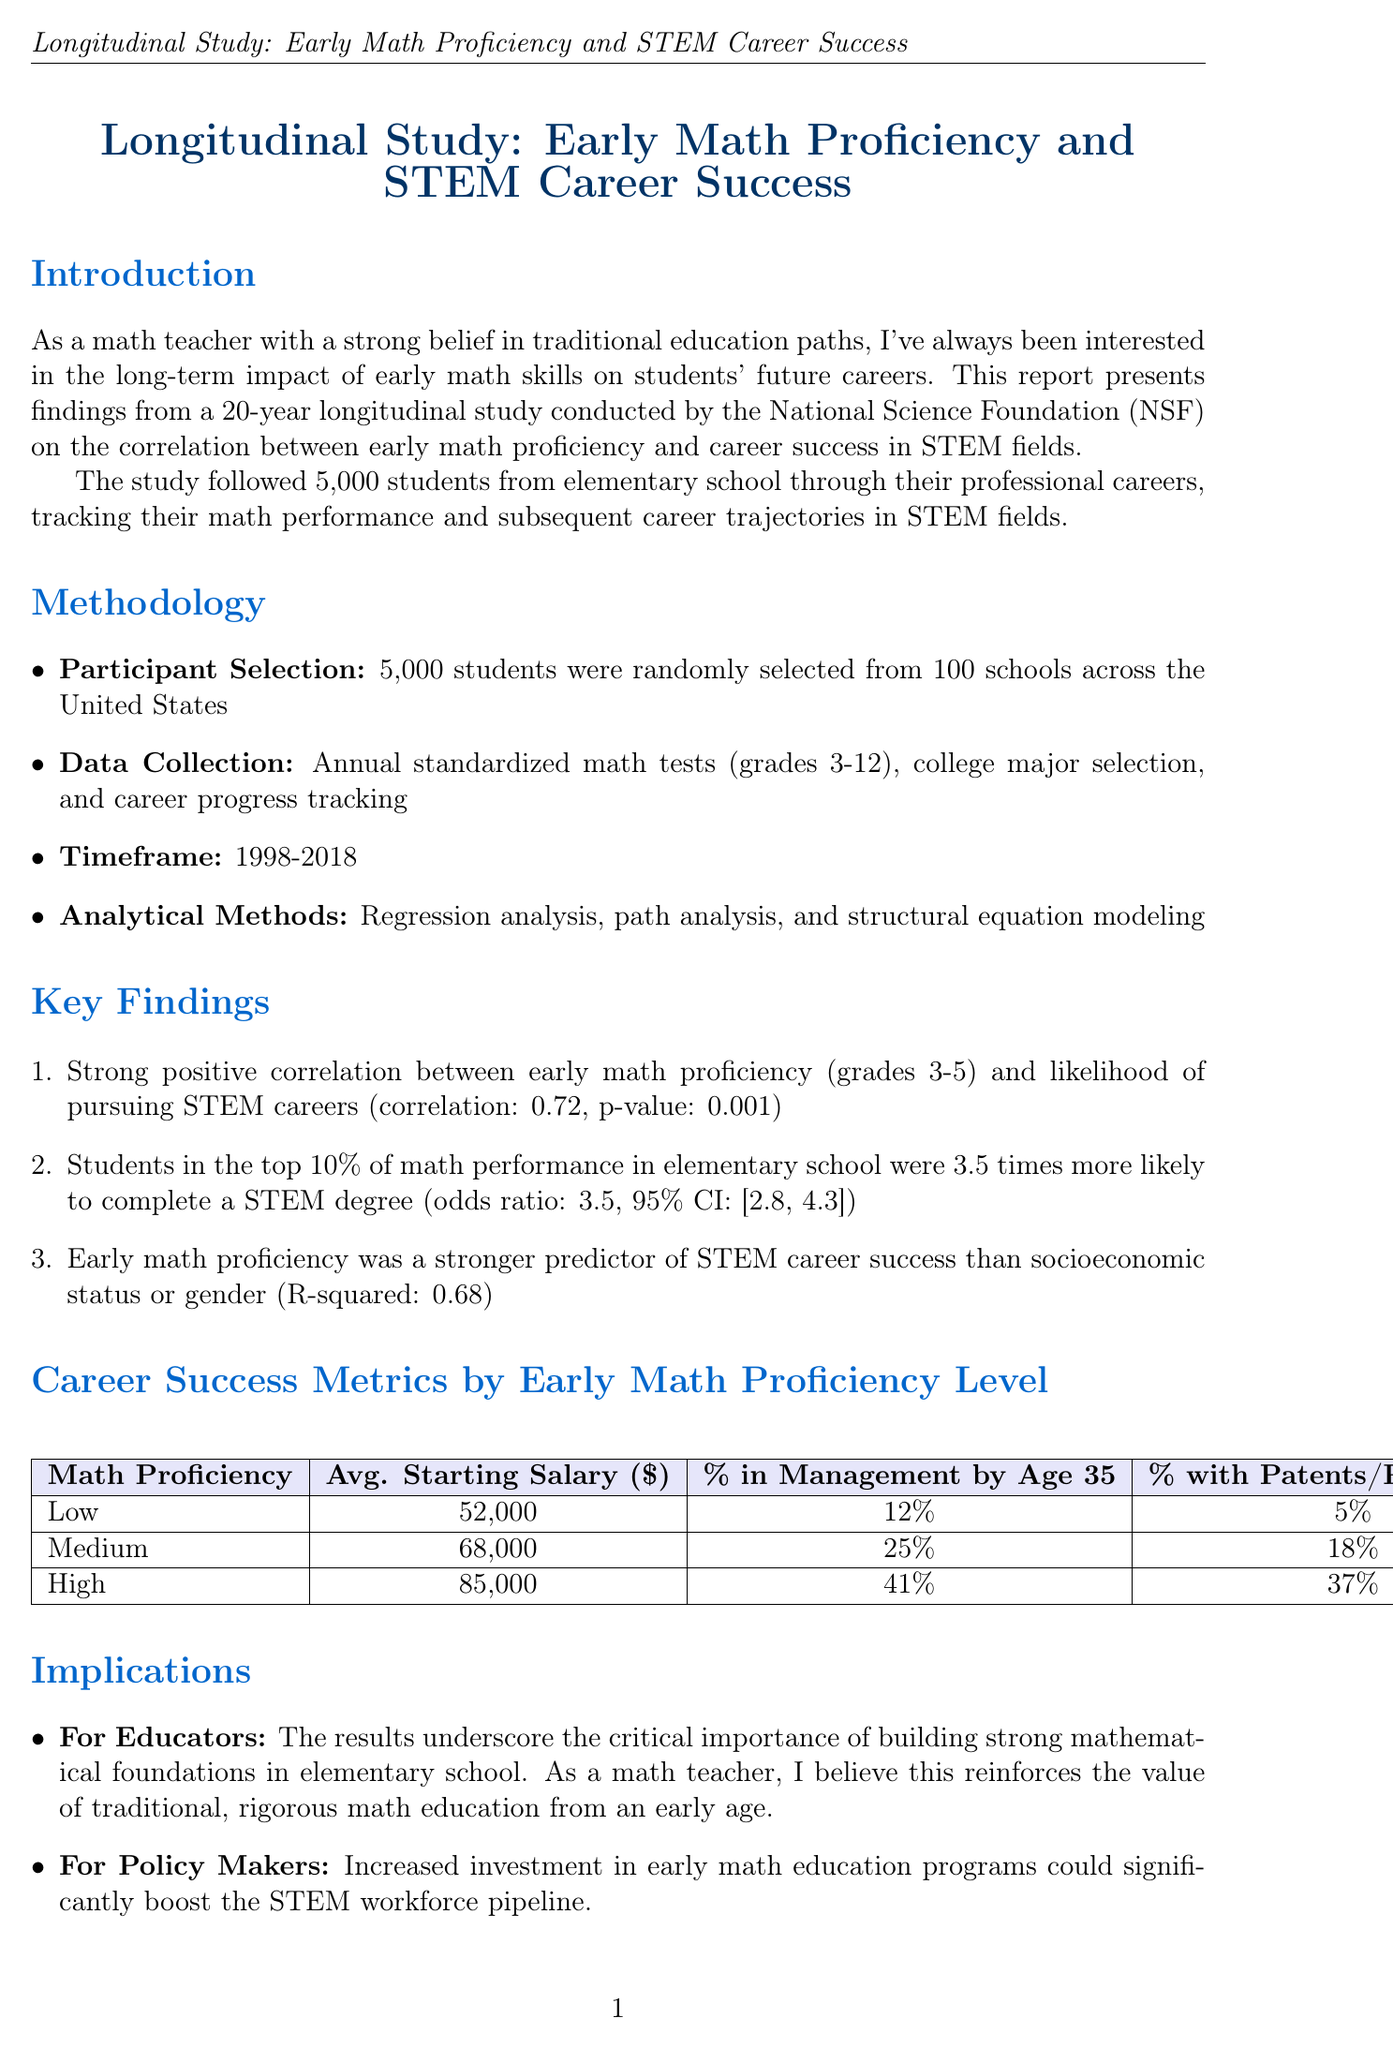what is the correlation coefficient between early math proficiency and likelihood of pursuing STEM careers? The correlation between early math proficiency and likelihood of pursuing STEM careers is indicated as 0.72 in the study.
Answer: 0.72 how many students were tracked in the study? The study followed a cohort of students, specifically 5,000 students, as mentioned in the introduction.
Answer: 5,000 what was the average starting salary for individuals with high early math proficiency? The average starting salary for individuals with high early math proficiency is provided in the findings, being $85,000.
Answer: $85,000 what percentage of students in the 91st-100th math proficiency percentile completed a STEM degree? The percentage of students who completed a STEM degree in the 91st-100th math proficiency percentile is calculated from the bar chart data as 78%.
Answer: 78% who conducted the longitudinal study? The longitudinal study was conducted by the National Science Foundation (NSF), as stated in the document.
Answer: National Science Foundation what was the timeframe of the study? The timeframe of the study is mentioned as being from 1998 to 2018.
Answer: 1998-2018 what is the odds ratio for students in the top 10% of math performance completing a STEM degree? The odds ratio indicating the likelihood of students in the top 10% of math performance completing a STEM degree is given as 3.5.
Answer: 3.5 what is one implication for policy makers based on the study? An implication for policy makers includes the suggestion that increased investment in early math education programs could significantly boost the STEM workforce pipeline.
Answer: Increased investment in early math education programs how does early math proficiency compare to socioeconomic status or gender in predicting STEM career success? The document indicates that early math proficiency was a stronger predictor of STEM career success than socioeconomic status or gender, which supports its critical role.
Answer: Stronger predictor than socioeconomic status or gender 